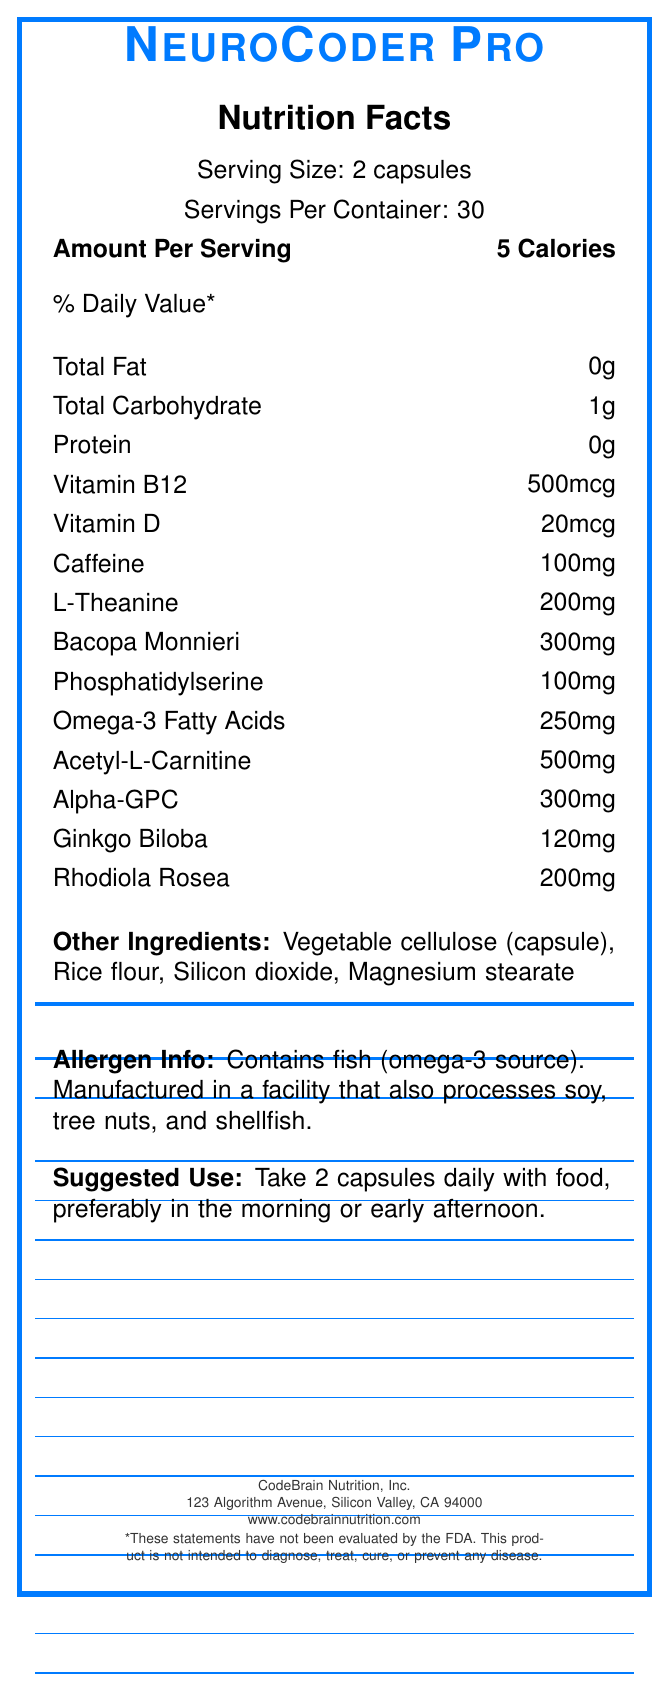what is the serving size for NeuroCoder Pro? The document states "Serving Size: 2 capsules."
Answer: 2 capsules how many calories are there per serving? The document mentions "Calories: 5" under the "Amount Per Serving" section.
Answer: 5 calories what is the amount of caffeine in one serving? The document shows "Caffeine: 100mg" in the list of ingredients per serving.
Answer: 100mg what are the other ingredients in this supplement? The document lists "Other Ingredients: Vegetable cellulose (capsule), Rice flour, Silicon dioxide, Magnesium stearate."
Answer: Vegetable cellulose (capsule), Rice flour, Silicon dioxide, Magnesium stearate what is the suggested use for this supplement? The document provides the suggested use as "Take 2 capsules daily with food, preferably in the morning or early afternoon."
Answer: Take 2 capsules daily with food, preferably in the morning or early afternoon which ingredient is present in the largest amount per serving? The highest quantity listed under the ingredients is "Acetyl-L-Carnitine: 500mg."
Answer: Acetyl-L-Carnitine what is the serving count per container? A. 60 B. 30 C. 15 D. 45 The document indicates "Servings Per Container: 30."
Answer: B. 30 which of these ingredients is directly associated with cognitive benefits? I. Bacopa Monnieri II. Silicon dioxide III. L-Theanine IV. Magnesium stearate Bacopa Monnieri and L-Theanine are known for their cognitive-enhancing properties.
Answer: I and III does the product contain any allergens? The allergen information states "Contains fish (omega-3 source). Manufactured in a facility that also processes soy, tree nuts, and shellfish."
Answer: Yes is this product intended for children under 18? The document states "Not intended for use by persons under 18."
Answer: No describe the overall purpose of the document The document contains various sections providing detailed information about the supplement NeuroCoder Pro, designed to inform users about the product's nutritional content, appropriate usage, and any precautions that should be taken.
Answer: The document is a Nutrition Facts Label for the NeuroCoder Pro supplement, detailing serving size, nutritional content, ingredients, suggested use, warnings, storage instructions, manufacturer information, and FDA disclaimer. is this product suitable for pregnant women? The document explicitly states "Do not use if pregnant or nursing."
Answer: No how long will one container of NeuroCoder Pro last if used as directed? Given that the serving size is 2 capsules and there are 30 servings per container, one container will last for 30 days when used as directed.
Answer: 30 days what is the address of the manufacturer? The document lists the manufacturer's address as "123 Algorithm Avenue, Silicon Valley, CA 94000."
Answer: 123 Algorithm Avenue, Silicon Valley, CA 94000 can you take this supplement at night? The suggested use advises taking the supplement "preferably in the morning or early afternoon," implying it should not be taken at night.
Answer: Not recommended how many ingredients are in the "other ingredients" section? The document lists four other ingredients: "Vegetable cellulose (capsule), Rice flour, Silicon dioxide, Magnesium stearate."
Answer: Four what is the percentage of daily value for vitamins included in the label? The document does not provide the percentage of daily value for the vitamins listed.
Answer: Cannot be determined 